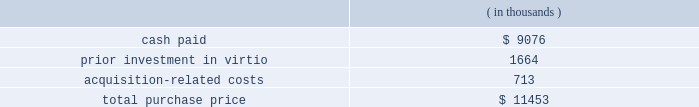Fair value of the tangible assets and identifiable intangible assets acquired , was $ 17.7 million .
Goodwill resulted primarily from the company 2019s expectation of synergies from the integration of sigma-c 2019s technology with the company 2019s technology and operations .
Virtio corporation , inc .
( virtio ) the company acquired virtio on may 15 , 2006 in an all-cash transaction .
Reasons for the acquisition .
The company believes that its acquisition of virtio will expand its presence in electronic system level design .
The company expects the combination of the company 2019s system studio solution with virtio 2019s virtual prototyping technology will help accelerate systems to market by giving software developers the ability to begin code development earlier than with prevailing methods .
Purchase price .
The company paid $ 9.1 million in cash for the outstanding shares of virtio , of which $ 0.9 million was deposited with an escrow agent and which will be paid to the former stockholders of virtio pursuant to the terms of an escrow agreement .
In addition , the company had a prior investment in virtio of approximately $ 1.7 million .
The total purchase consideration consisted of: .
Acquisition-related costs of $ 0.7 million consist primarily of legal , tax and accounting fees , estimated facilities closure costs and employee termination costs .
As of october 31 , 2006 , the company had paid $ 0.3 million of the acquisition-related costs .
The $ 0.4 million balance remaining at october 31 , 2006 primarily consists of professional and tax-related service fees and facilities closure costs .
Under the agreement with virtio , the company has also agreed to pay up to $ 4.3 million over three years to the former stockholders based upon achievement of certain sales milestones .
This contingent consideration is considered to be additional purchase price and will be an adjustment to goodwill when and if payment is made .
Additionally , the company has also agreed to pay $ 0.9 million in employee retention bonuses which will be recognized as compensation expense over the service period of the applicable employees .
Assets acquired .
The company has performed a preliminary valuation and allocated the total purchase consideration to the assets and liabilities acquired , including identifiable intangible assets based on their respective fair values on the acquisition date .
The company acquired $ 2.5 million of intangible assets consisting of $ 1.9 million in existing technology , $ 0.4 million in customer relationships and $ 0.2 million in non-compete agreements to be amortized over five to seven years .
Additionally , the company acquired tangible assets of $ 5.5 million and assumed liabilities of $ 3.2 million .
Goodwill , representing the excess of the purchase price over the fair value of the net tangible and identifiable intangible assets acquired in the merger , was $ 6.7 million .
Goodwill resulted primarily from the company 2019s expectation of synergies from the integration of virtio 2019s technology with the company 2019s technology and operations .
Hpl technologies , inc .
( hpl ) the company acquired hpl on december 7 , 2005 in an all-cash transaction .
Reasons for the acquisition .
The company believes that the acquisition of hpl will help solidify the company 2019s position as a leading electronic design automation vendor in design for manufacturing ( dfm ) .
What percentage of the total purchase price did goodwill represent? 
Computations: (6.7 * 1000)
Answer: 6700.0. 